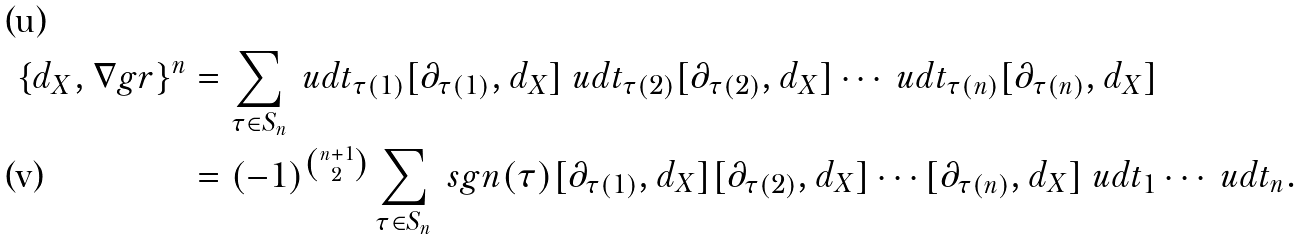Convert formula to latex. <formula><loc_0><loc_0><loc_500><loc_500>\{ d _ { X } , \nabla g r \} ^ { n } & = \sum _ { \tau \in S _ { n } } \ u d t _ { \tau ( 1 ) } [ \partial _ { \tau ( 1 ) } , d _ { X } ] \ u d t _ { \tau ( 2 ) } [ \partial _ { \tau ( 2 ) } , d _ { X } ] \cdots \ u d t _ { \tau ( n ) } [ \partial _ { \tau ( n ) } , d _ { X } ] \\ & = ( - 1 ) ^ { \binom { n + 1 } { 2 } } \sum _ { \tau \in S _ { n } } \ s g n ( \tau ) [ \partial _ { \tau ( 1 ) } , d _ { X } ] [ \partial _ { \tau ( 2 ) } , d _ { X } ] \cdots [ \partial _ { \tau ( n ) } , d _ { X } ] \ u d t _ { 1 } \cdots \ u d t _ { n } .</formula> 